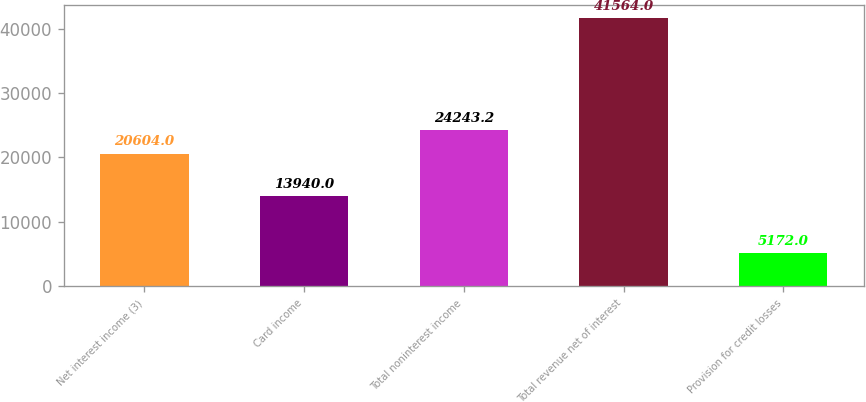Convert chart. <chart><loc_0><loc_0><loc_500><loc_500><bar_chart><fcel>Net interest income (3)<fcel>Card income<fcel>Total noninterest income<fcel>Total revenue net of interest<fcel>Provision for credit losses<nl><fcel>20604<fcel>13940<fcel>24243.2<fcel>41564<fcel>5172<nl></chart> 